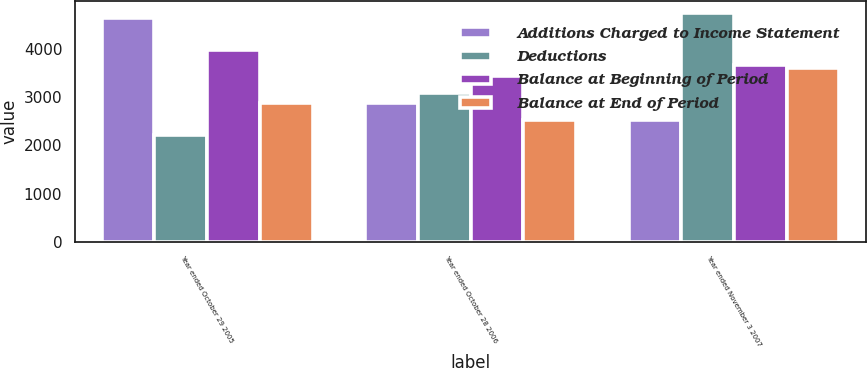Convert chart to OTSL. <chart><loc_0><loc_0><loc_500><loc_500><stacked_bar_chart><ecel><fcel>Year ended October 29 2005<fcel>Year ended October 28 2006<fcel>Year ended November 3 2007<nl><fcel>Additions Charged to Income Statement<fcel>4645<fcel>2882<fcel>2533<nl><fcel>Deductions<fcel>2216<fcel>3087<fcel>4753<nl><fcel>Balance at Beginning of Period<fcel>3979<fcel>3436<fcel>3675<nl><fcel>Balance at End of Period<fcel>2882<fcel>2533<fcel>3611<nl></chart> 